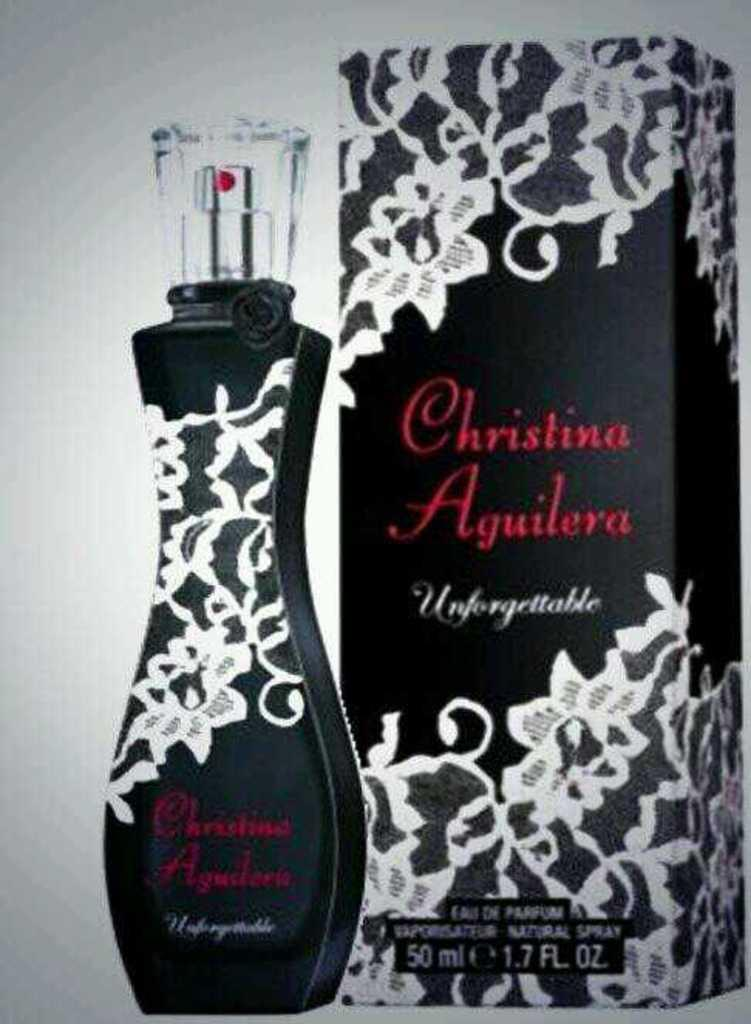<image>
Relay a brief, clear account of the picture shown. A bottle of Christina Aguilera Unforgettable sits next to its box. 